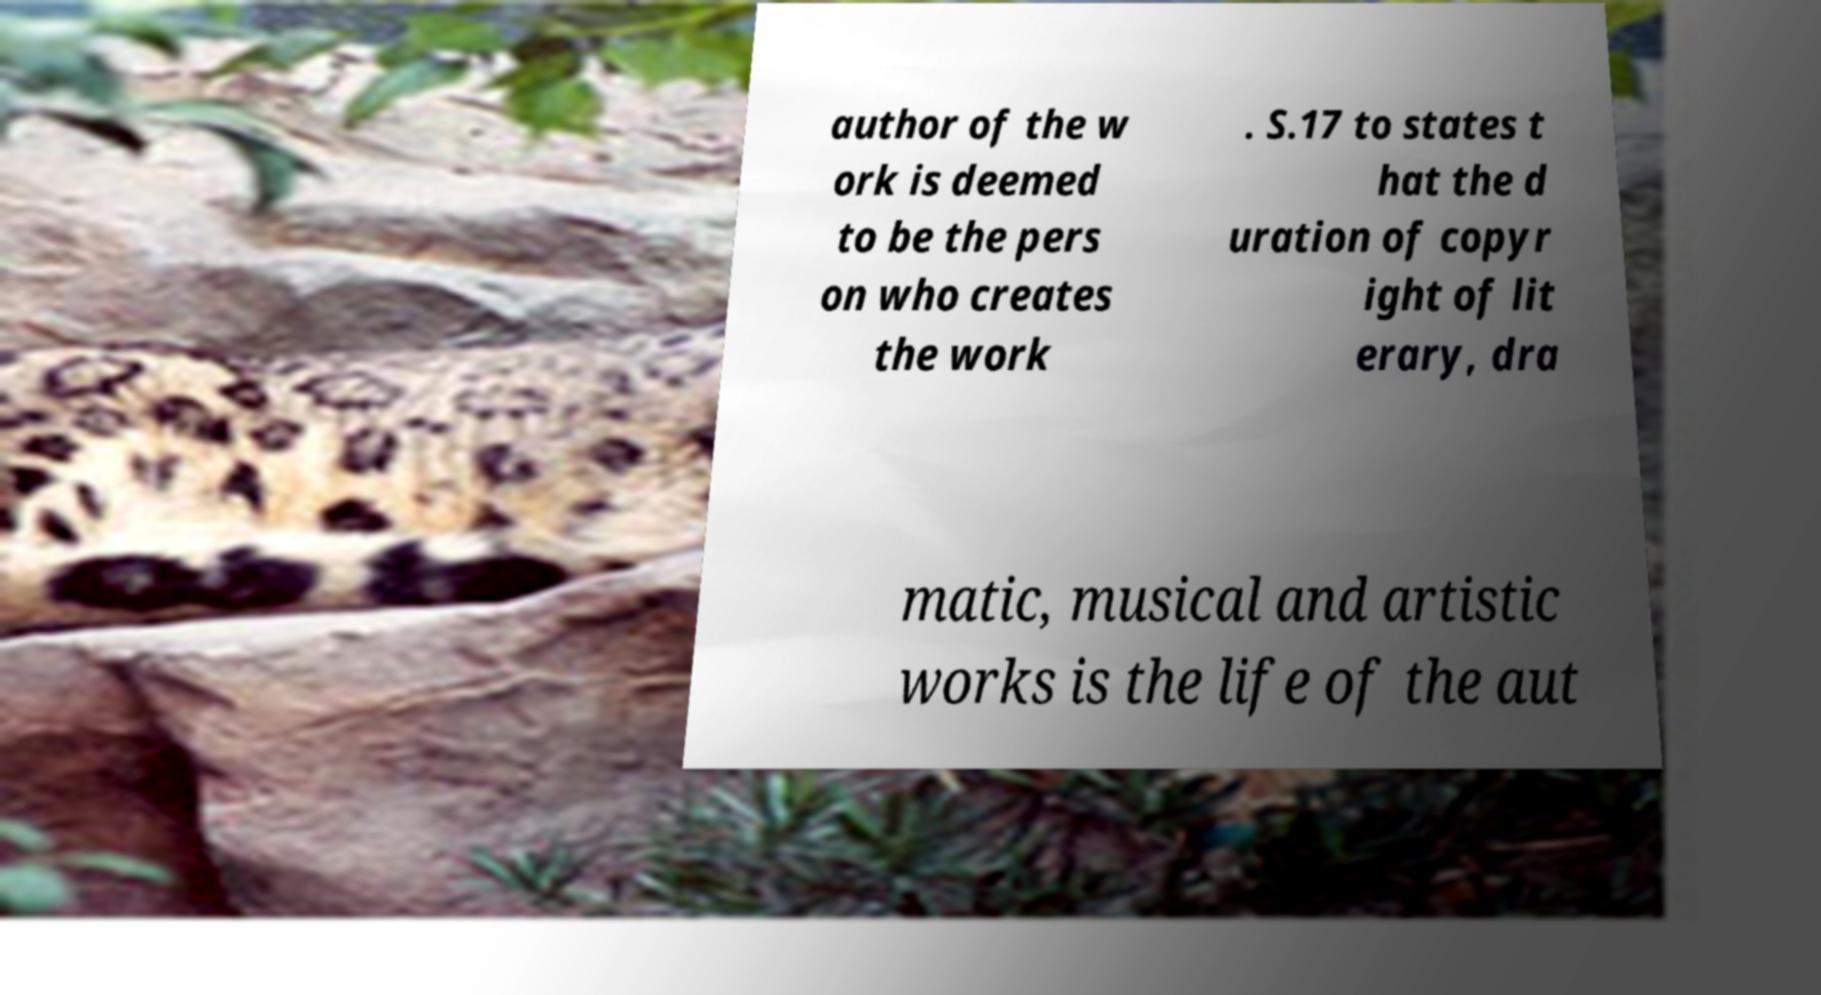Can you read and provide the text displayed in the image?This photo seems to have some interesting text. Can you extract and type it out for me? author of the w ork is deemed to be the pers on who creates the work . S.17 to states t hat the d uration of copyr ight of lit erary, dra matic, musical and artistic works is the life of the aut 